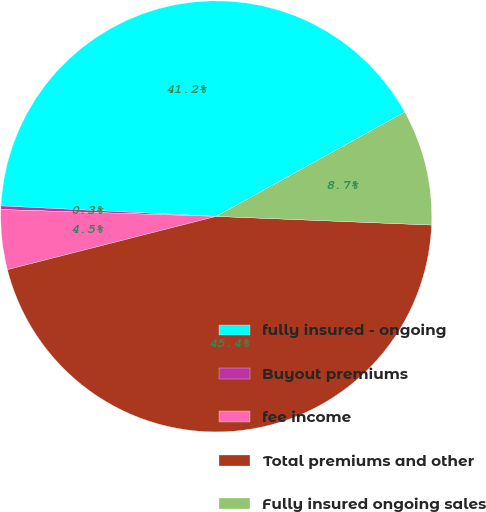<chart> <loc_0><loc_0><loc_500><loc_500><pie_chart><fcel>fully insured - ongoing<fcel>Buyout premiums<fcel>fee income<fcel>Total premiums and other<fcel>Fully insured ongoing sales<nl><fcel>41.19%<fcel>0.27%<fcel>4.48%<fcel>45.39%<fcel>8.68%<nl></chart> 